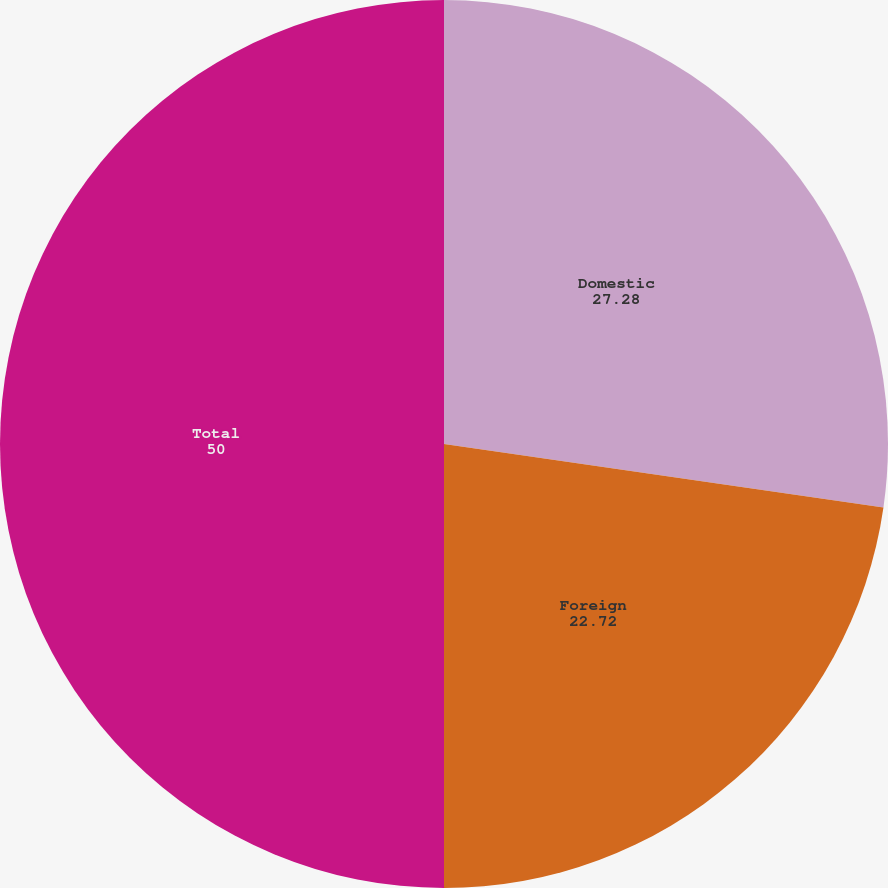Convert chart. <chart><loc_0><loc_0><loc_500><loc_500><pie_chart><fcel>Domestic<fcel>Foreign<fcel>Total<nl><fcel>27.28%<fcel>22.72%<fcel>50.0%<nl></chart> 